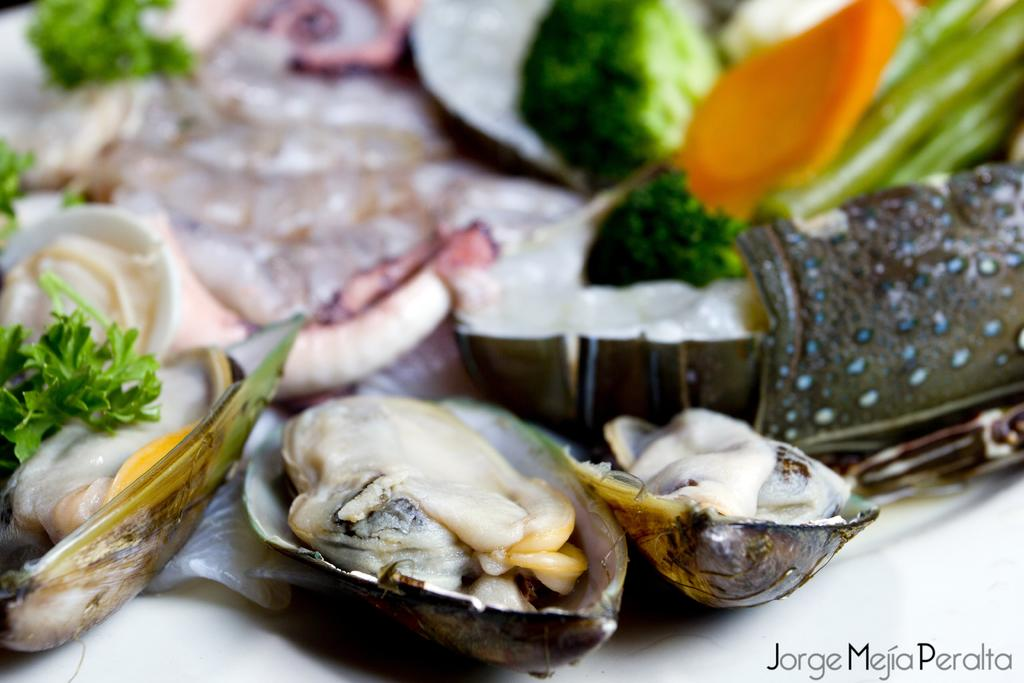What can be seen in the image? There is a group of food items in the image. Where are the food items located? The food items are on a platform. What type of comb is being used by the father in the image? There is no father or comb present in the image; it only features a group of food items on a platform. 